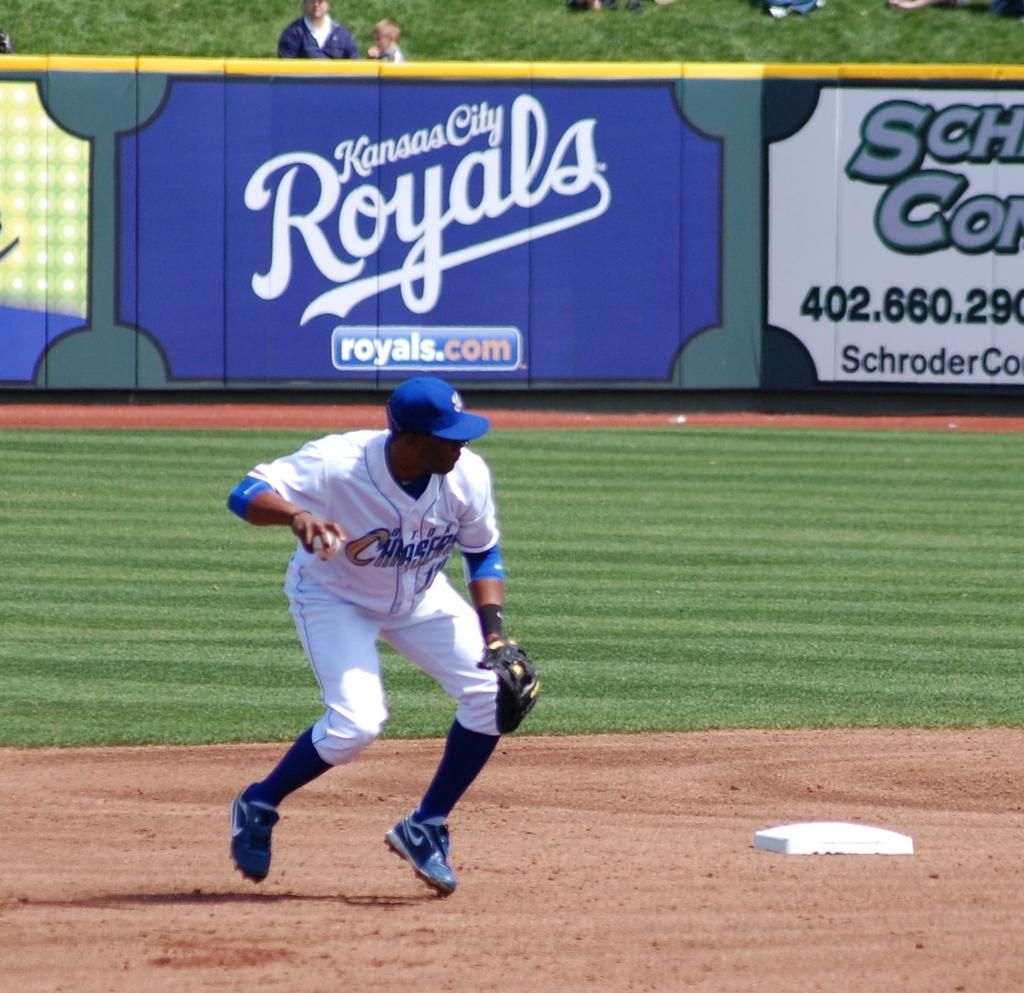<image>
Share a concise interpretation of the image provided. A large sign on the field for the Kansas City Royals. 